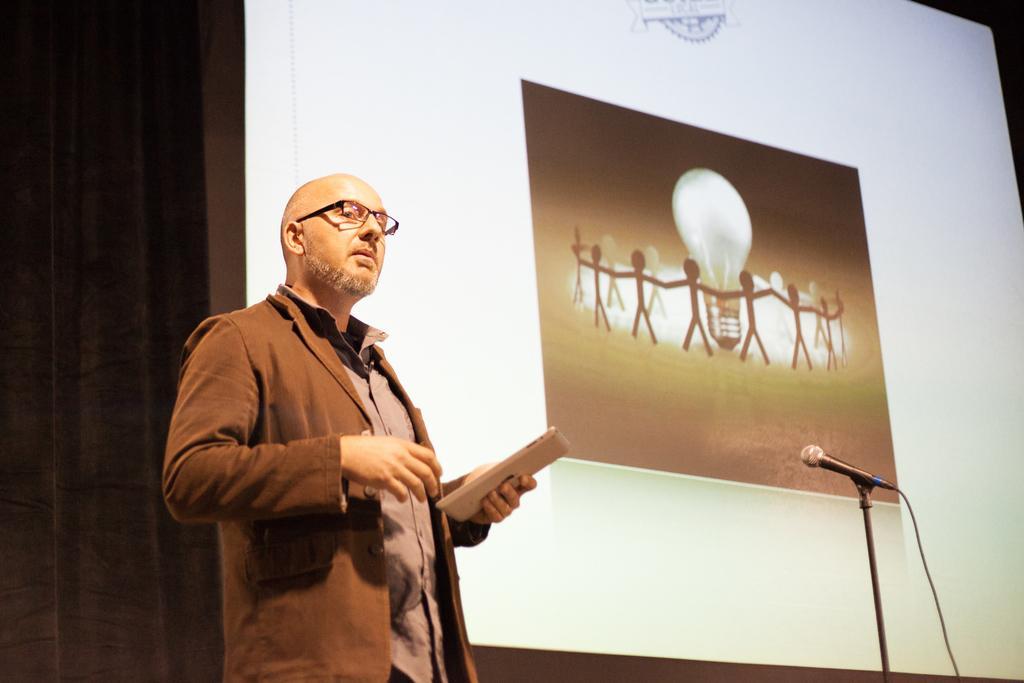Please provide a concise description of this image. In the front of the image I can see a person and mic stand. Person wore a jacket and holding an object. In the background of the image there is a screen. I can see a picture on the screen.   